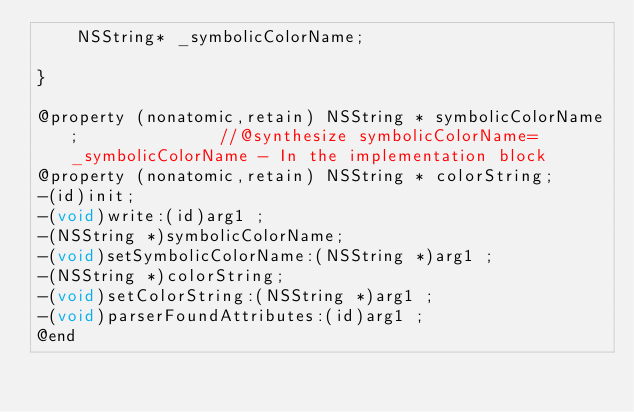<code> <loc_0><loc_0><loc_500><loc_500><_C_>	NSString* _symbolicColorName;

}

@property (nonatomic,retain) NSString * symbolicColorName;              //@synthesize symbolicColorName=_symbolicColorName - In the implementation block
@property (nonatomic,retain) NSString * colorString; 
-(id)init;
-(void)write:(id)arg1 ;
-(NSString *)symbolicColorName;
-(void)setSymbolicColorName:(NSString *)arg1 ;
-(NSString *)colorString;
-(void)setColorString:(NSString *)arg1 ;
-(void)parserFoundAttributes:(id)arg1 ;
@end

</code> 